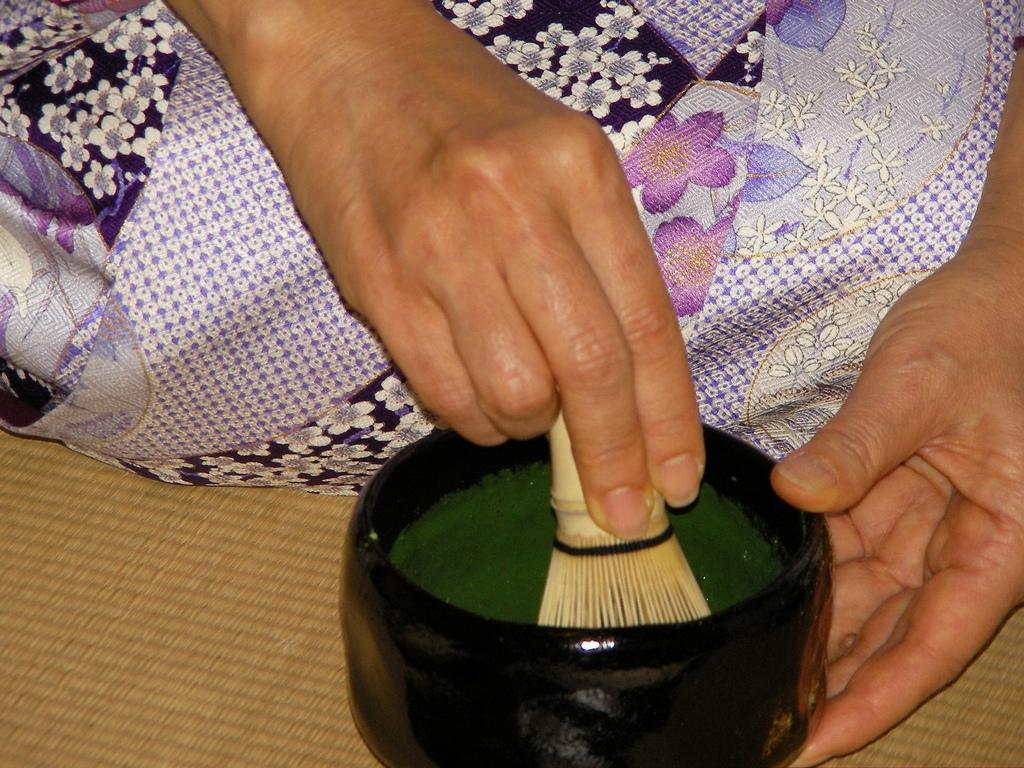How would you summarize this image in a sentence or two? In this picture we see someone's hands mixing green color in a black bowl using a brush. 